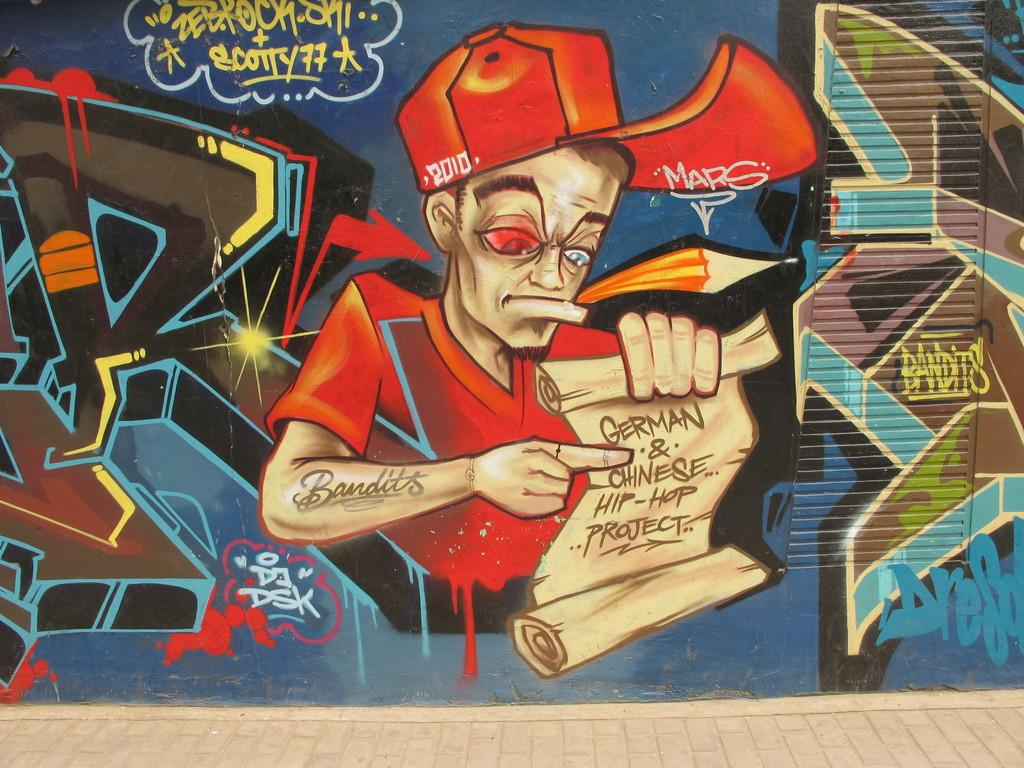What is on the wall in the image? There is a painting on the wall in the image. What is the subject of the painting? The painting depicts a man. What is the man holding in the painting? The man is holding some notes in the painting. How is the man's hand represented in the painting? The man's hand is drawn on the wall in the painting. What type of wood is used to create the man's ear in the painting? There is no wood or ear present in the painting; it depicts a man holding notes with his hand drawn on the wall. 